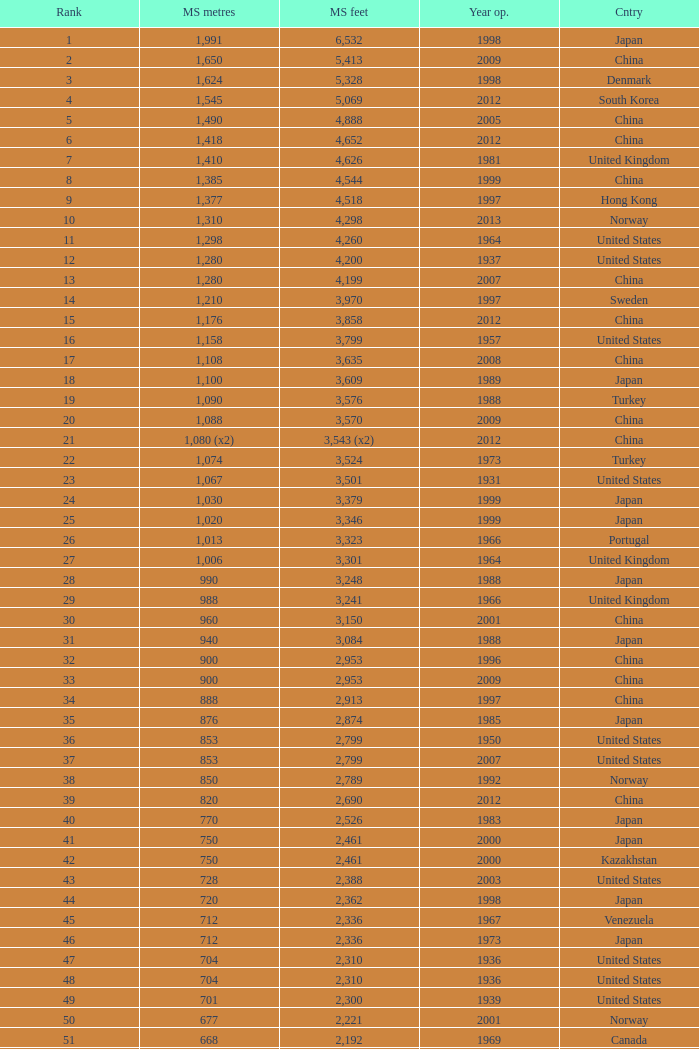What is the principal span in feet from a year of 2009 or more current with a rank lesser than 94 and 1,310 main span meters? 4298.0. 